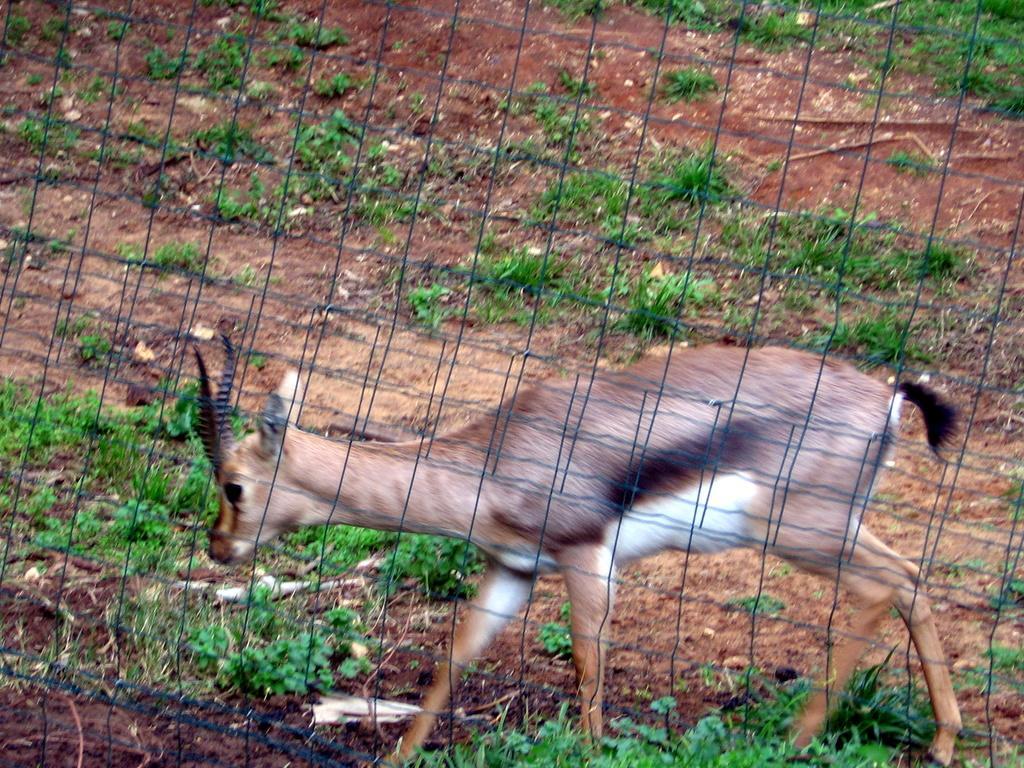Please provide a concise description of this image. This picture is clicked outside. In the foreground we can see the net and an animal seems to be walking on the ground and we can see the plants and some other items. 